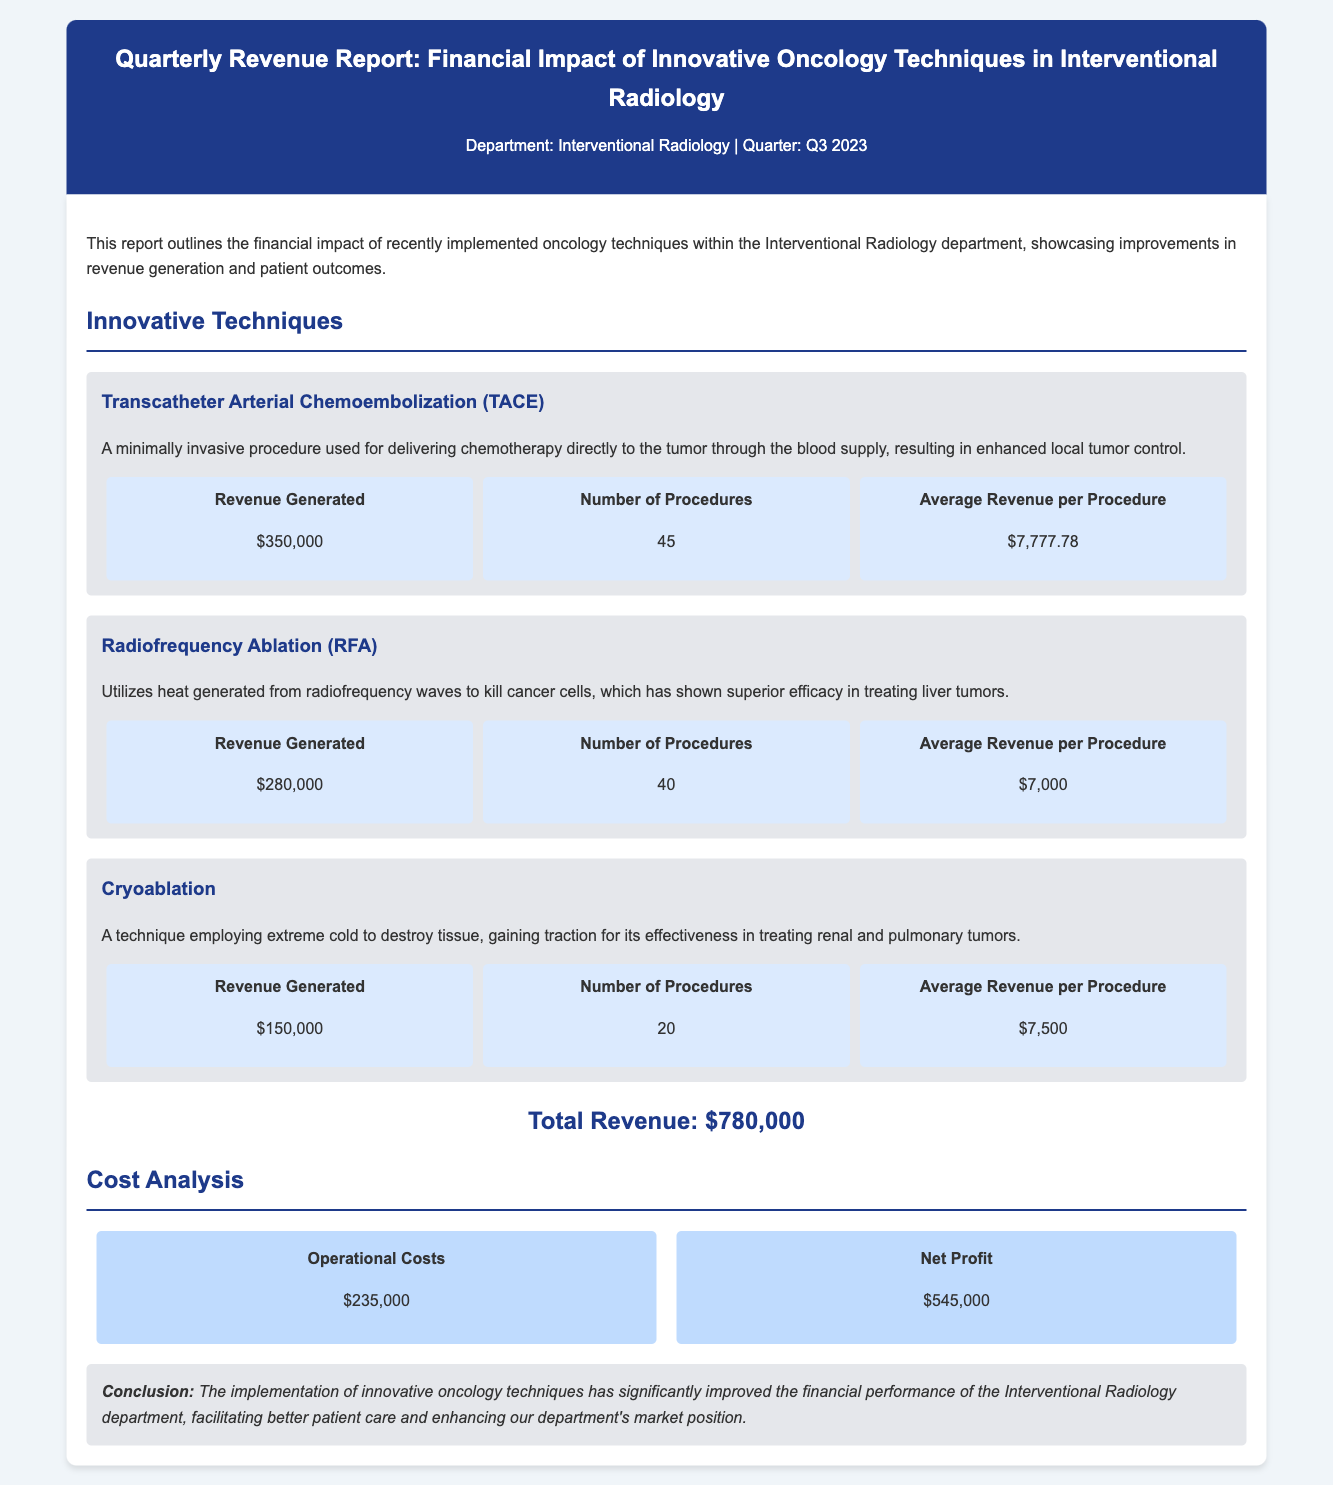What is the total revenue? The total revenue is calculated from the revenue generated by each innovative technique, which amounts to $350,000 + $280,000 + $150,000 = $780,000.
Answer: $780,000 How many procedures were performed using Radiofrequency Ablation? The number of procedures performed for Radiofrequency Ablation is stated in the document.
Answer: 40 What is the revenue generated from Transcatheter Arterial Chemoembolization? The document specifies the revenue generated by TACE as $350,000.
Answer: $350,000 What is the average revenue per procedure for Cryoablation? The average revenue per procedure for Cryoablation is directly mentioned in the document.
Answer: $7,500 What are the operational costs reported? The operational costs are listed in the financial section of the report.
Answer: $235,000 What is the net profit for the quarter? The net profit is calculated by deducting operational costs from total revenue, which is $780,000 - $235,000.
Answer: $545,000 Which innovative technique generated the least revenue? The innovative technique with the least revenue is indicated in the financial impact section.
Answer: Cryoablation What procedure is highlighted as a minimally invasive technique? The document highlights a specific procedure characterized as minimally invasive.
Answer: Transcatheter Arterial Chemoembolization What conclusion is drawn about the financial performance of the department? The conclusion summarizes the overall effect of the innovations on financial performance.
Answer: Significantly improved 